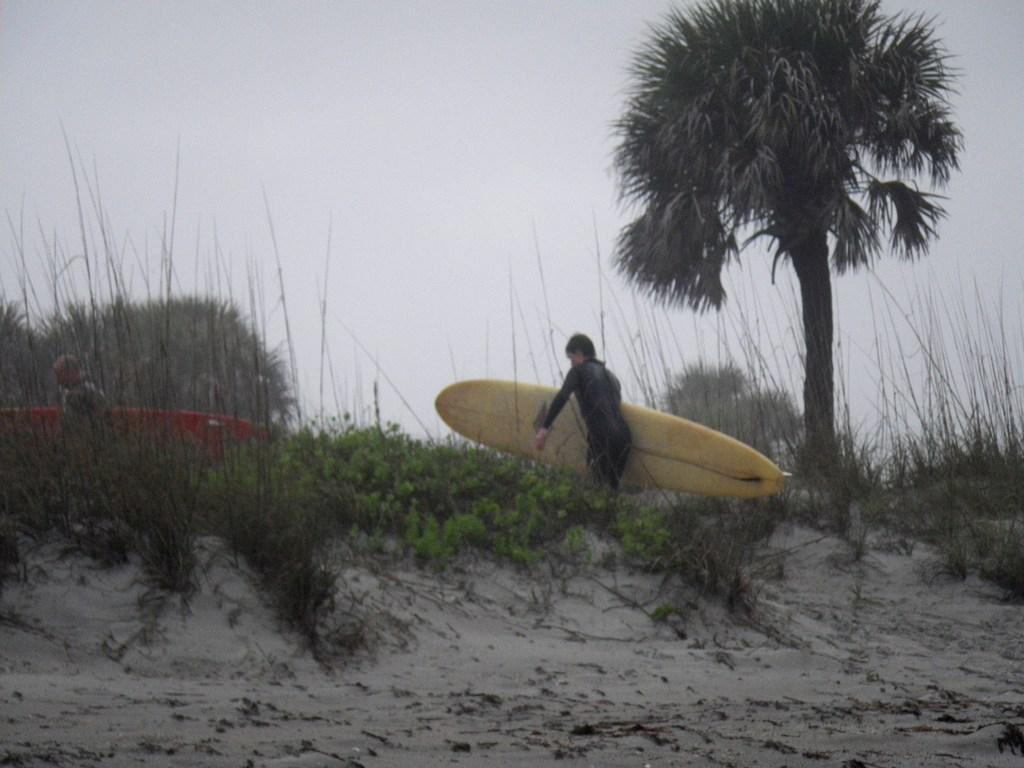Who or what is present in the image? There is a person in the image. What is the person holding in the image? The person is holding a water skiing device. What type of natural environment can be seen in the image? There are trees visible in the image. What is visible in the background of the image? The sky is visible in the image. What type of root can be seen growing from the person's foot in the image? There is no root growing from the person's foot in the image. What type of cushion is the person sitting on in the image? The person is not sitting on a cushion in the image; they are holding a water skiing device. 